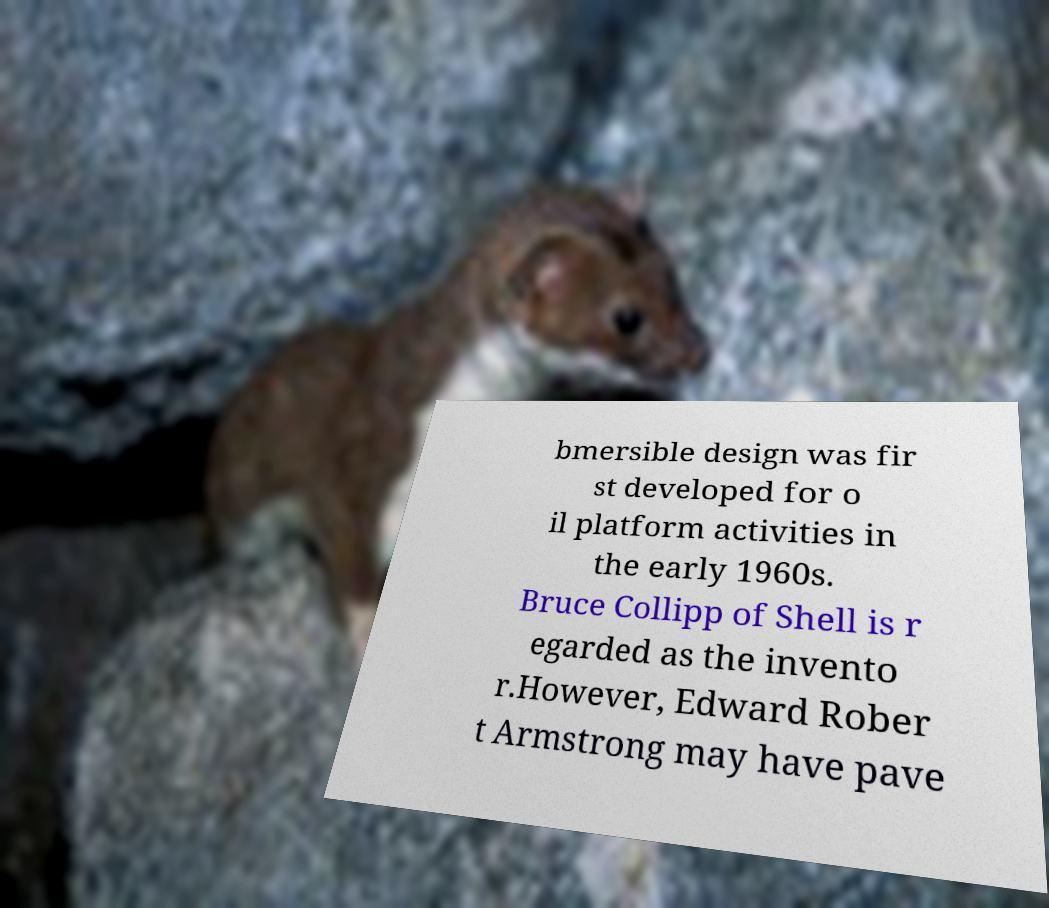For documentation purposes, I need the text within this image transcribed. Could you provide that? bmersible design was fir st developed for o il platform activities in the early 1960s. Bruce Collipp of Shell is r egarded as the invento r.However, Edward Rober t Armstrong may have pave 